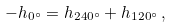Convert formula to latex. <formula><loc_0><loc_0><loc_500><loc_500>- h _ { 0 ^ { \circ } } = h _ { 2 4 0 ^ { \circ } } + h _ { 1 2 0 ^ { \circ } } \, ,</formula> 